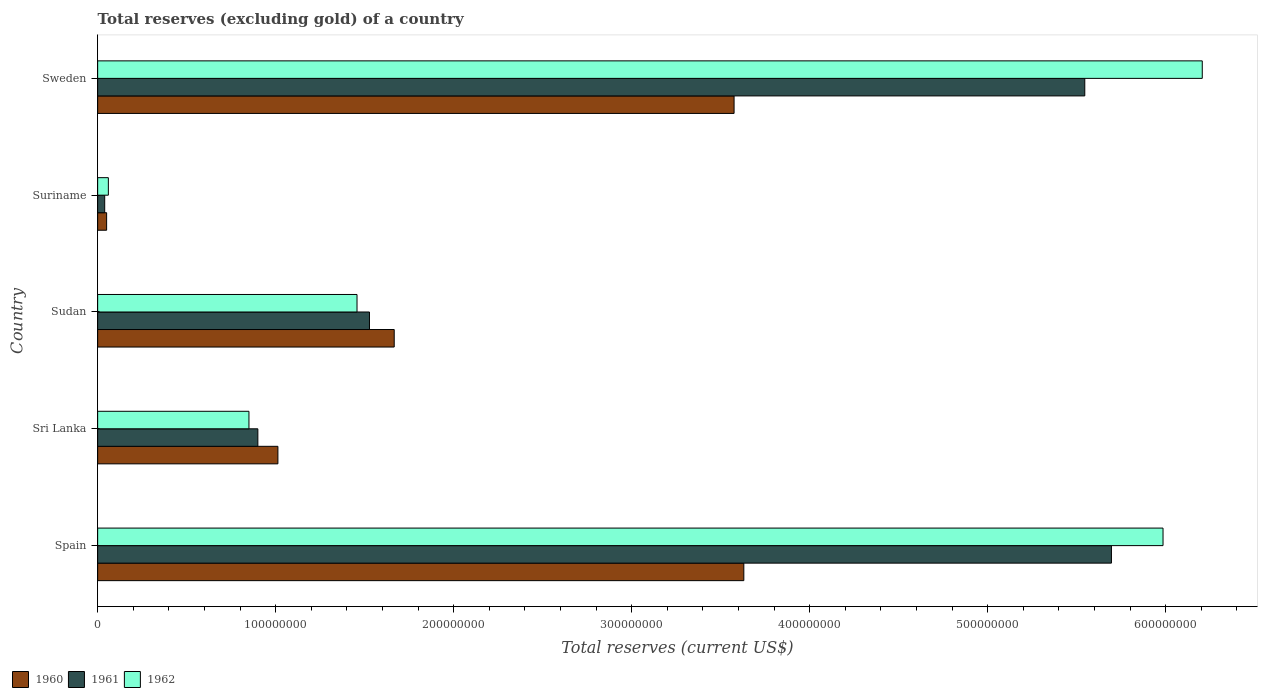How many groups of bars are there?
Your answer should be compact. 5. Are the number of bars per tick equal to the number of legend labels?
Give a very brief answer. Yes. Are the number of bars on each tick of the Y-axis equal?
Offer a very short reply. Yes. How many bars are there on the 5th tick from the bottom?
Provide a short and direct response. 3. What is the label of the 4th group of bars from the top?
Your response must be concise. Sri Lanka. What is the total reserves (excluding gold) in 1960 in Sri Lanka?
Keep it short and to the point. 1.01e+08. Across all countries, what is the maximum total reserves (excluding gold) in 1961?
Provide a short and direct response. 5.70e+08. Across all countries, what is the minimum total reserves (excluding gold) in 1962?
Your response must be concise. 6.01e+06. In which country was the total reserves (excluding gold) in 1962 minimum?
Keep it short and to the point. Suriname. What is the total total reserves (excluding gold) in 1960 in the graph?
Provide a short and direct response. 9.93e+08. What is the difference between the total reserves (excluding gold) in 1962 in Spain and that in Sri Lanka?
Your answer should be very brief. 5.13e+08. What is the difference between the total reserves (excluding gold) in 1961 in Sudan and the total reserves (excluding gold) in 1962 in Suriname?
Keep it short and to the point. 1.47e+08. What is the average total reserves (excluding gold) in 1960 per country?
Ensure brevity in your answer.  1.99e+08. What is the difference between the total reserves (excluding gold) in 1962 and total reserves (excluding gold) in 1960 in Suriname?
Ensure brevity in your answer.  9.68e+05. In how many countries, is the total reserves (excluding gold) in 1962 greater than 480000000 US$?
Your response must be concise. 2. What is the ratio of the total reserves (excluding gold) in 1962 in Spain to that in Sudan?
Your answer should be very brief. 4.11. Is the total reserves (excluding gold) in 1960 in Spain less than that in Sudan?
Your response must be concise. No. What is the difference between the highest and the second highest total reserves (excluding gold) in 1960?
Give a very brief answer. 5.47e+06. What is the difference between the highest and the lowest total reserves (excluding gold) in 1962?
Provide a short and direct response. 6.15e+08. Is the sum of the total reserves (excluding gold) in 1961 in Sudan and Suriname greater than the maximum total reserves (excluding gold) in 1960 across all countries?
Your response must be concise. No. What does the 3rd bar from the top in Sweden represents?
Make the answer very short. 1960. How many bars are there?
Provide a succinct answer. 15. Are all the bars in the graph horizontal?
Provide a succinct answer. Yes. Are the values on the major ticks of X-axis written in scientific E-notation?
Ensure brevity in your answer.  No. Does the graph contain any zero values?
Your answer should be compact. No. Does the graph contain grids?
Give a very brief answer. No. Where does the legend appear in the graph?
Provide a short and direct response. Bottom left. How many legend labels are there?
Make the answer very short. 3. How are the legend labels stacked?
Offer a terse response. Horizontal. What is the title of the graph?
Give a very brief answer. Total reserves (excluding gold) of a country. Does "1979" appear as one of the legend labels in the graph?
Provide a succinct answer. No. What is the label or title of the X-axis?
Provide a short and direct response. Total reserves (current US$). What is the Total reserves (current US$) of 1960 in Spain?
Provide a succinct answer. 3.63e+08. What is the Total reserves (current US$) of 1961 in Spain?
Give a very brief answer. 5.70e+08. What is the Total reserves (current US$) in 1962 in Spain?
Your answer should be compact. 5.98e+08. What is the Total reserves (current US$) of 1960 in Sri Lanka?
Your answer should be compact. 1.01e+08. What is the Total reserves (current US$) in 1961 in Sri Lanka?
Your answer should be very brief. 9.00e+07. What is the Total reserves (current US$) of 1962 in Sri Lanka?
Your answer should be compact. 8.50e+07. What is the Total reserves (current US$) of 1960 in Sudan?
Keep it short and to the point. 1.67e+08. What is the Total reserves (current US$) in 1961 in Sudan?
Keep it short and to the point. 1.53e+08. What is the Total reserves (current US$) in 1962 in Sudan?
Make the answer very short. 1.46e+08. What is the Total reserves (current US$) in 1960 in Suriname?
Provide a short and direct response. 5.04e+06. What is the Total reserves (current US$) of 1961 in Suriname?
Give a very brief answer. 3.96e+06. What is the Total reserves (current US$) of 1962 in Suriname?
Give a very brief answer. 6.01e+06. What is the Total reserves (current US$) of 1960 in Sweden?
Your answer should be compact. 3.58e+08. What is the Total reserves (current US$) in 1961 in Sweden?
Your answer should be very brief. 5.55e+08. What is the Total reserves (current US$) of 1962 in Sweden?
Your response must be concise. 6.21e+08. Across all countries, what is the maximum Total reserves (current US$) of 1960?
Your response must be concise. 3.63e+08. Across all countries, what is the maximum Total reserves (current US$) in 1961?
Ensure brevity in your answer.  5.70e+08. Across all countries, what is the maximum Total reserves (current US$) in 1962?
Give a very brief answer. 6.21e+08. Across all countries, what is the minimum Total reserves (current US$) in 1960?
Your answer should be compact. 5.04e+06. Across all countries, what is the minimum Total reserves (current US$) in 1961?
Your answer should be compact. 3.96e+06. Across all countries, what is the minimum Total reserves (current US$) in 1962?
Your response must be concise. 6.01e+06. What is the total Total reserves (current US$) of 1960 in the graph?
Keep it short and to the point. 9.93e+08. What is the total Total reserves (current US$) in 1961 in the graph?
Keep it short and to the point. 1.37e+09. What is the total Total reserves (current US$) in 1962 in the graph?
Your answer should be very brief. 1.46e+09. What is the difference between the Total reserves (current US$) of 1960 in Spain and that in Sri Lanka?
Offer a terse response. 2.62e+08. What is the difference between the Total reserves (current US$) of 1961 in Spain and that in Sri Lanka?
Offer a very short reply. 4.80e+08. What is the difference between the Total reserves (current US$) in 1962 in Spain and that in Sri Lanka?
Give a very brief answer. 5.13e+08. What is the difference between the Total reserves (current US$) of 1960 in Spain and that in Sudan?
Offer a terse response. 1.96e+08. What is the difference between the Total reserves (current US$) of 1961 in Spain and that in Sudan?
Make the answer very short. 4.17e+08. What is the difference between the Total reserves (current US$) of 1962 in Spain and that in Sudan?
Keep it short and to the point. 4.53e+08. What is the difference between the Total reserves (current US$) of 1960 in Spain and that in Suriname?
Provide a succinct answer. 3.58e+08. What is the difference between the Total reserves (current US$) in 1961 in Spain and that in Suriname?
Offer a terse response. 5.66e+08. What is the difference between the Total reserves (current US$) of 1962 in Spain and that in Suriname?
Ensure brevity in your answer.  5.92e+08. What is the difference between the Total reserves (current US$) in 1960 in Spain and that in Sweden?
Make the answer very short. 5.47e+06. What is the difference between the Total reserves (current US$) in 1961 in Spain and that in Sweden?
Your answer should be very brief. 1.50e+07. What is the difference between the Total reserves (current US$) of 1962 in Spain and that in Sweden?
Offer a terse response. -2.20e+07. What is the difference between the Total reserves (current US$) in 1960 in Sri Lanka and that in Sudan?
Make the answer very short. -6.53e+07. What is the difference between the Total reserves (current US$) in 1961 in Sri Lanka and that in Sudan?
Your answer should be compact. -6.27e+07. What is the difference between the Total reserves (current US$) of 1962 in Sri Lanka and that in Sudan?
Offer a terse response. -6.07e+07. What is the difference between the Total reserves (current US$) in 1960 in Sri Lanka and that in Suriname?
Provide a short and direct response. 9.62e+07. What is the difference between the Total reserves (current US$) in 1961 in Sri Lanka and that in Suriname?
Your answer should be compact. 8.60e+07. What is the difference between the Total reserves (current US$) in 1962 in Sri Lanka and that in Suriname?
Make the answer very short. 7.90e+07. What is the difference between the Total reserves (current US$) of 1960 in Sri Lanka and that in Sweden?
Make the answer very short. -2.56e+08. What is the difference between the Total reserves (current US$) of 1961 in Sri Lanka and that in Sweden?
Your response must be concise. -4.65e+08. What is the difference between the Total reserves (current US$) in 1962 in Sri Lanka and that in Sweden?
Your answer should be compact. -5.36e+08. What is the difference between the Total reserves (current US$) in 1960 in Sudan and that in Suriname?
Provide a succinct answer. 1.62e+08. What is the difference between the Total reserves (current US$) of 1961 in Sudan and that in Suriname?
Keep it short and to the point. 1.49e+08. What is the difference between the Total reserves (current US$) of 1962 in Sudan and that in Suriname?
Provide a succinct answer. 1.40e+08. What is the difference between the Total reserves (current US$) of 1960 in Sudan and that in Sweden?
Your response must be concise. -1.91e+08. What is the difference between the Total reserves (current US$) in 1961 in Sudan and that in Sweden?
Your response must be concise. -4.02e+08. What is the difference between the Total reserves (current US$) in 1962 in Sudan and that in Sweden?
Provide a succinct answer. -4.75e+08. What is the difference between the Total reserves (current US$) of 1960 in Suriname and that in Sweden?
Your response must be concise. -3.52e+08. What is the difference between the Total reserves (current US$) of 1961 in Suriname and that in Sweden?
Keep it short and to the point. -5.51e+08. What is the difference between the Total reserves (current US$) in 1962 in Suriname and that in Sweden?
Your answer should be very brief. -6.15e+08. What is the difference between the Total reserves (current US$) in 1960 in Spain and the Total reserves (current US$) in 1961 in Sri Lanka?
Offer a terse response. 2.73e+08. What is the difference between the Total reserves (current US$) of 1960 in Spain and the Total reserves (current US$) of 1962 in Sri Lanka?
Provide a succinct answer. 2.78e+08. What is the difference between the Total reserves (current US$) of 1961 in Spain and the Total reserves (current US$) of 1962 in Sri Lanka?
Your response must be concise. 4.85e+08. What is the difference between the Total reserves (current US$) in 1960 in Spain and the Total reserves (current US$) in 1961 in Sudan?
Offer a terse response. 2.10e+08. What is the difference between the Total reserves (current US$) in 1960 in Spain and the Total reserves (current US$) in 1962 in Sudan?
Provide a short and direct response. 2.17e+08. What is the difference between the Total reserves (current US$) of 1961 in Spain and the Total reserves (current US$) of 1962 in Sudan?
Provide a short and direct response. 4.24e+08. What is the difference between the Total reserves (current US$) of 1960 in Spain and the Total reserves (current US$) of 1961 in Suriname?
Provide a succinct answer. 3.59e+08. What is the difference between the Total reserves (current US$) in 1960 in Spain and the Total reserves (current US$) in 1962 in Suriname?
Your answer should be very brief. 3.57e+08. What is the difference between the Total reserves (current US$) of 1961 in Spain and the Total reserves (current US$) of 1962 in Suriname?
Keep it short and to the point. 5.64e+08. What is the difference between the Total reserves (current US$) of 1960 in Spain and the Total reserves (current US$) of 1961 in Sweden?
Offer a very short reply. -1.92e+08. What is the difference between the Total reserves (current US$) in 1960 in Spain and the Total reserves (current US$) in 1962 in Sweden?
Offer a very short reply. -2.58e+08. What is the difference between the Total reserves (current US$) of 1961 in Spain and the Total reserves (current US$) of 1962 in Sweden?
Offer a very short reply. -5.10e+07. What is the difference between the Total reserves (current US$) in 1960 in Sri Lanka and the Total reserves (current US$) in 1961 in Sudan?
Your answer should be very brief. -5.14e+07. What is the difference between the Total reserves (current US$) of 1960 in Sri Lanka and the Total reserves (current US$) of 1962 in Sudan?
Your answer should be compact. -4.44e+07. What is the difference between the Total reserves (current US$) of 1961 in Sri Lanka and the Total reserves (current US$) of 1962 in Sudan?
Make the answer very short. -5.57e+07. What is the difference between the Total reserves (current US$) of 1960 in Sri Lanka and the Total reserves (current US$) of 1961 in Suriname?
Provide a succinct answer. 9.73e+07. What is the difference between the Total reserves (current US$) in 1960 in Sri Lanka and the Total reserves (current US$) in 1962 in Suriname?
Your answer should be compact. 9.52e+07. What is the difference between the Total reserves (current US$) in 1961 in Sri Lanka and the Total reserves (current US$) in 1962 in Suriname?
Ensure brevity in your answer.  8.40e+07. What is the difference between the Total reserves (current US$) in 1960 in Sri Lanka and the Total reserves (current US$) in 1961 in Sweden?
Keep it short and to the point. -4.53e+08. What is the difference between the Total reserves (current US$) of 1960 in Sri Lanka and the Total reserves (current US$) of 1962 in Sweden?
Your response must be concise. -5.19e+08. What is the difference between the Total reserves (current US$) in 1961 in Sri Lanka and the Total reserves (current US$) in 1962 in Sweden?
Offer a very short reply. -5.31e+08. What is the difference between the Total reserves (current US$) of 1960 in Sudan and the Total reserves (current US$) of 1961 in Suriname?
Offer a terse response. 1.63e+08. What is the difference between the Total reserves (current US$) of 1960 in Sudan and the Total reserves (current US$) of 1962 in Suriname?
Provide a succinct answer. 1.61e+08. What is the difference between the Total reserves (current US$) of 1961 in Sudan and the Total reserves (current US$) of 1962 in Suriname?
Offer a very short reply. 1.47e+08. What is the difference between the Total reserves (current US$) of 1960 in Sudan and the Total reserves (current US$) of 1961 in Sweden?
Give a very brief answer. -3.88e+08. What is the difference between the Total reserves (current US$) in 1960 in Sudan and the Total reserves (current US$) in 1962 in Sweden?
Your response must be concise. -4.54e+08. What is the difference between the Total reserves (current US$) of 1961 in Sudan and the Total reserves (current US$) of 1962 in Sweden?
Offer a terse response. -4.68e+08. What is the difference between the Total reserves (current US$) of 1960 in Suriname and the Total reserves (current US$) of 1961 in Sweden?
Offer a terse response. -5.49e+08. What is the difference between the Total reserves (current US$) in 1960 in Suriname and the Total reserves (current US$) in 1962 in Sweden?
Your answer should be very brief. -6.15e+08. What is the difference between the Total reserves (current US$) in 1961 in Suriname and the Total reserves (current US$) in 1962 in Sweden?
Offer a terse response. -6.17e+08. What is the average Total reserves (current US$) in 1960 per country?
Keep it short and to the point. 1.99e+08. What is the average Total reserves (current US$) in 1961 per country?
Offer a very short reply. 2.74e+08. What is the average Total reserves (current US$) in 1962 per country?
Your response must be concise. 2.91e+08. What is the difference between the Total reserves (current US$) in 1960 and Total reserves (current US$) in 1961 in Spain?
Your answer should be compact. -2.07e+08. What is the difference between the Total reserves (current US$) of 1960 and Total reserves (current US$) of 1962 in Spain?
Keep it short and to the point. -2.35e+08. What is the difference between the Total reserves (current US$) in 1961 and Total reserves (current US$) in 1962 in Spain?
Give a very brief answer. -2.90e+07. What is the difference between the Total reserves (current US$) of 1960 and Total reserves (current US$) of 1961 in Sri Lanka?
Give a very brief answer. 1.13e+07. What is the difference between the Total reserves (current US$) in 1960 and Total reserves (current US$) in 1962 in Sri Lanka?
Offer a terse response. 1.63e+07. What is the difference between the Total reserves (current US$) in 1960 and Total reserves (current US$) in 1961 in Sudan?
Ensure brevity in your answer.  1.39e+07. What is the difference between the Total reserves (current US$) of 1960 and Total reserves (current US$) of 1962 in Sudan?
Provide a succinct answer. 2.09e+07. What is the difference between the Total reserves (current US$) of 1961 and Total reserves (current US$) of 1962 in Sudan?
Provide a succinct answer. 7.00e+06. What is the difference between the Total reserves (current US$) in 1960 and Total reserves (current US$) in 1961 in Suriname?
Your answer should be very brief. 1.08e+06. What is the difference between the Total reserves (current US$) of 1960 and Total reserves (current US$) of 1962 in Suriname?
Your answer should be compact. -9.68e+05. What is the difference between the Total reserves (current US$) of 1961 and Total reserves (current US$) of 1962 in Suriname?
Keep it short and to the point. -2.05e+06. What is the difference between the Total reserves (current US$) in 1960 and Total reserves (current US$) in 1961 in Sweden?
Offer a very short reply. -1.97e+08. What is the difference between the Total reserves (current US$) of 1960 and Total reserves (current US$) of 1962 in Sweden?
Offer a very short reply. -2.63e+08. What is the difference between the Total reserves (current US$) in 1961 and Total reserves (current US$) in 1962 in Sweden?
Keep it short and to the point. -6.60e+07. What is the ratio of the Total reserves (current US$) in 1960 in Spain to that in Sri Lanka?
Provide a short and direct response. 3.58. What is the ratio of the Total reserves (current US$) of 1961 in Spain to that in Sri Lanka?
Keep it short and to the point. 6.33. What is the ratio of the Total reserves (current US$) of 1962 in Spain to that in Sri Lanka?
Keep it short and to the point. 7.04. What is the ratio of the Total reserves (current US$) in 1960 in Spain to that in Sudan?
Your response must be concise. 2.18. What is the ratio of the Total reserves (current US$) of 1961 in Spain to that in Sudan?
Offer a very short reply. 3.73. What is the ratio of the Total reserves (current US$) of 1962 in Spain to that in Sudan?
Keep it short and to the point. 4.11. What is the ratio of the Total reserves (current US$) in 1960 in Spain to that in Suriname?
Offer a terse response. 71.98. What is the ratio of the Total reserves (current US$) of 1961 in Spain to that in Suriname?
Offer a terse response. 143.78. What is the ratio of the Total reserves (current US$) of 1962 in Spain to that in Suriname?
Give a very brief answer. 99.57. What is the ratio of the Total reserves (current US$) in 1960 in Spain to that in Sweden?
Offer a terse response. 1.02. What is the ratio of the Total reserves (current US$) of 1961 in Spain to that in Sweden?
Give a very brief answer. 1.03. What is the ratio of the Total reserves (current US$) of 1962 in Spain to that in Sweden?
Provide a succinct answer. 0.96. What is the ratio of the Total reserves (current US$) in 1960 in Sri Lanka to that in Sudan?
Give a very brief answer. 0.61. What is the ratio of the Total reserves (current US$) of 1961 in Sri Lanka to that in Sudan?
Provide a short and direct response. 0.59. What is the ratio of the Total reserves (current US$) of 1962 in Sri Lanka to that in Sudan?
Make the answer very short. 0.58. What is the ratio of the Total reserves (current US$) of 1960 in Sri Lanka to that in Suriname?
Offer a terse response. 20.08. What is the ratio of the Total reserves (current US$) of 1961 in Sri Lanka to that in Suriname?
Offer a terse response. 22.72. What is the ratio of the Total reserves (current US$) in 1962 in Sri Lanka to that in Suriname?
Your response must be concise. 14.14. What is the ratio of the Total reserves (current US$) in 1960 in Sri Lanka to that in Sweden?
Your answer should be very brief. 0.28. What is the ratio of the Total reserves (current US$) in 1961 in Sri Lanka to that in Sweden?
Your answer should be compact. 0.16. What is the ratio of the Total reserves (current US$) in 1962 in Sri Lanka to that in Sweden?
Your answer should be compact. 0.14. What is the ratio of the Total reserves (current US$) in 1960 in Sudan to that in Suriname?
Provide a succinct answer. 33.04. What is the ratio of the Total reserves (current US$) of 1961 in Sudan to that in Suriname?
Ensure brevity in your answer.  38.55. What is the ratio of the Total reserves (current US$) in 1962 in Sudan to that in Suriname?
Give a very brief answer. 24.24. What is the ratio of the Total reserves (current US$) in 1960 in Sudan to that in Sweden?
Provide a short and direct response. 0.47. What is the ratio of the Total reserves (current US$) in 1961 in Sudan to that in Sweden?
Give a very brief answer. 0.28. What is the ratio of the Total reserves (current US$) of 1962 in Sudan to that in Sweden?
Offer a terse response. 0.23. What is the ratio of the Total reserves (current US$) in 1960 in Suriname to that in Sweden?
Your answer should be compact. 0.01. What is the ratio of the Total reserves (current US$) of 1961 in Suriname to that in Sweden?
Your response must be concise. 0.01. What is the ratio of the Total reserves (current US$) of 1962 in Suriname to that in Sweden?
Offer a very short reply. 0.01. What is the difference between the highest and the second highest Total reserves (current US$) in 1960?
Offer a terse response. 5.47e+06. What is the difference between the highest and the second highest Total reserves (current US$) in 1961?
Make the answer very short. 1.50e+07. What is the difference between the highest and the second highest Total reserves (current US$) of 1962?
Your response must be concise. 2.20e+07. What is the difference between the highest and the lowest Total reserves (current US$) in 1960?
Your answer should be compact. 3.58e+08. What is the difference between the highest and the lowest Total reserves (current US$) in 1961?
Ensure brevity in your answer.  5.66e+08. What is the difference between the highest and the lowest Total reserves (current US$) in 1962?
Ensure brevity in your answer.  6.15e+08. 